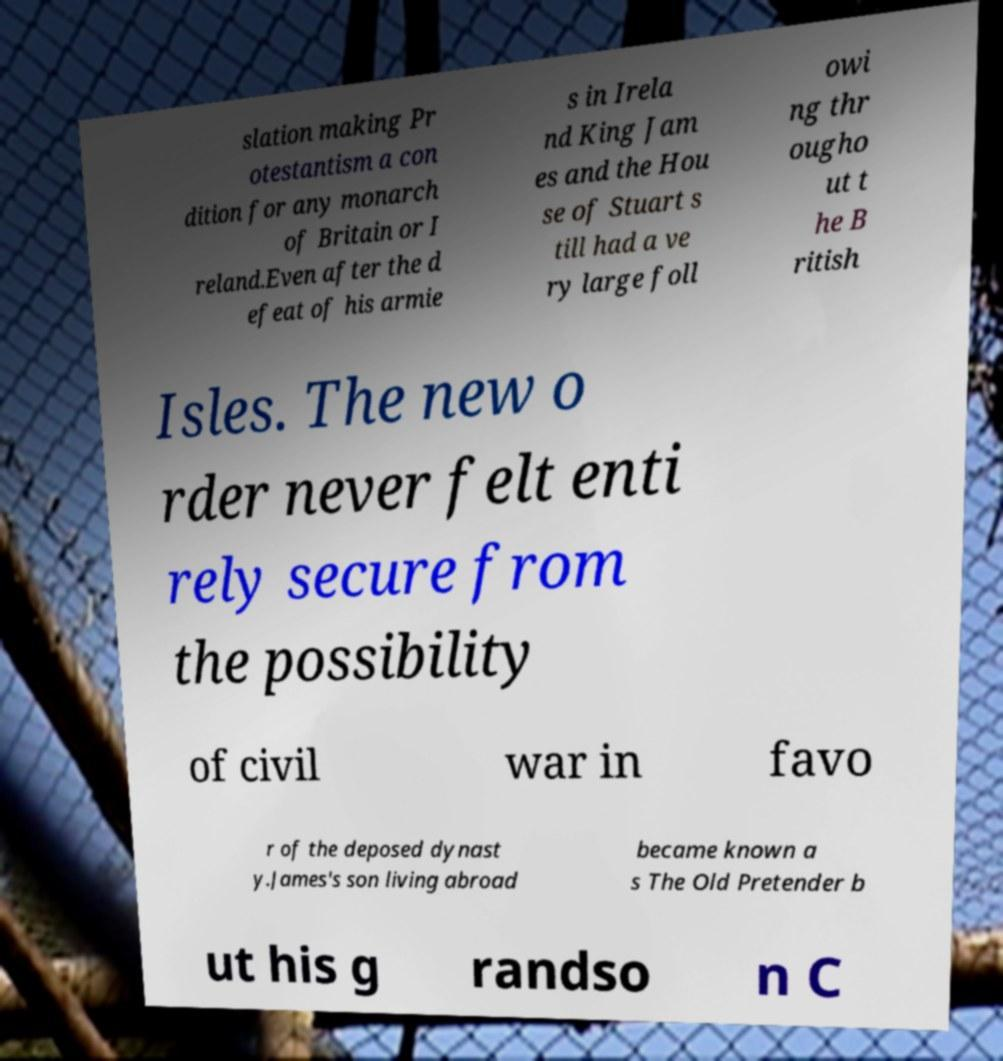Please read and relay the text visible in this image. What does it say? slation making Pr otestantism a con dition for any monarch of Britain or I reland.Even after the d efeat of his armie s in Irela nd King Jam es and the Hou se of Stuart s till had a ve ry large foll owi ng thr ougho ut t he B ritish Isles. The new o rder never felt enti rely secure from the possibility of civil war in favo r of the deposed dynast y.James's son living abroad became known a s The Old Pretender b ut his g randso n C 